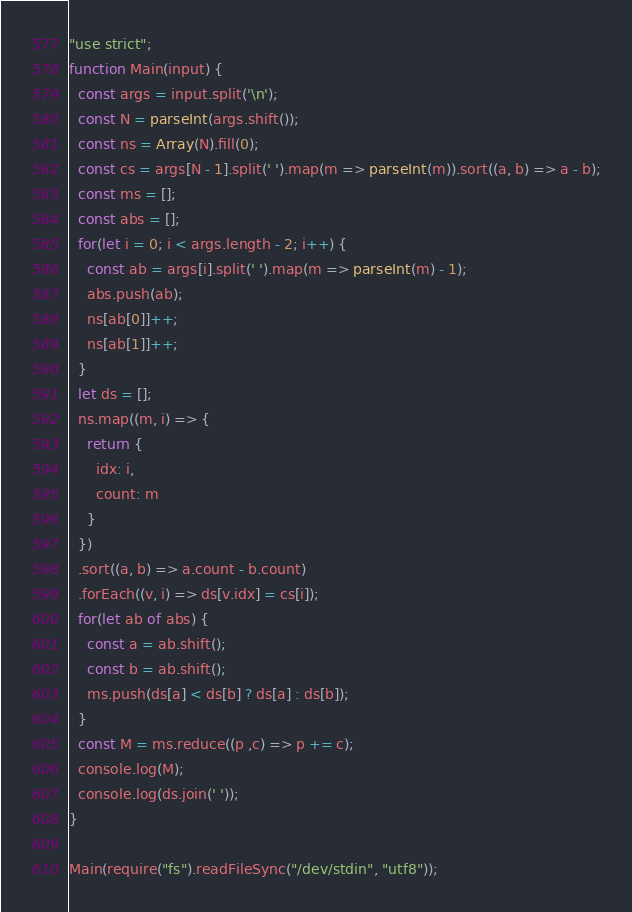Convert code to text. <code><loc_0><loc_0><loc_500><loc_500><_JavaScript_>"use strict";
function Main(input) {
  const args = input.split('\n');
  const N = parseInt(args.shift());
  const ns = Array(N).fill(0);
  const cs = args[N - 1].split(' ').map(m => parseInt(m)).sort((a, b) => a - b);
  const ms = [];
  const abs = [];
  for(let i = 0; i < args.length - 2; i++) {
    const ab = args[i].split(' ').map(m => parseInt(m) - 1);
    abs.push(ab);
    ns[ab[0]]++;
    ns[ab[1]]++;
  }
  let ds = [];
  ns.map((m, i) => {
    return {
      idx: i,
      count: m
    }
  })
  .sort((a, b) => a.count - b.count)
  .forEach((v, i) => ds[v.idx] = cs[i]);
  for(let ab of abs) {
    const a = ab.shift();
    const b = ab.shift();
    ms.push(ds[a] < ds[b] ? ds[a] : ds[b]);
  }
  const M = ms.reduce((p ,c) => p += c);
  console.log(M);
  console.log(ds.join(' '));
}

Main(require("fs").readFileSync("/dev/stdin", "utf8"));
</code> 